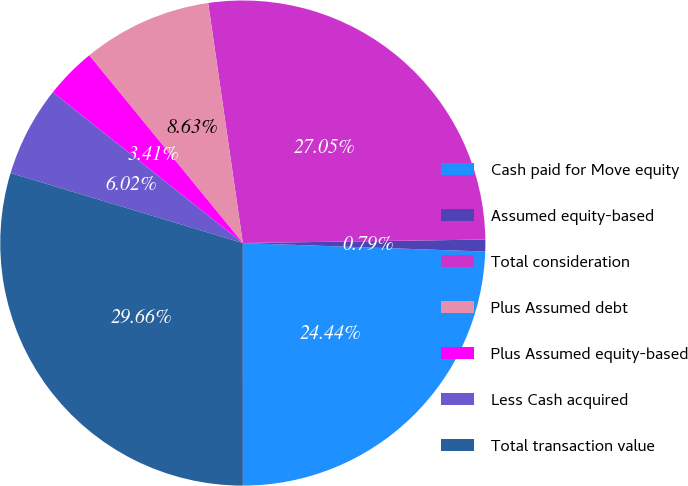Convert chart to OTSL. <chart><loc_0><loc_0><loc_500><loc_500><pie_chart><fcel>Cash paid for Move equity<fcel>Assumed equity-based<fcel>Total consideration<fcel>Plus Assumed debt<fcel>Plus Assumed equity-based<fcel>Less Cash acquired<fcel>Total transaction value<nl><fcel>24.44%<fcel>0.79%<fcel>27.05%<fcel>8.63%<fcel>3.41%<fcel>6.02%<fcel>29.66%<nl></chart> 